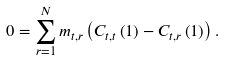<formula> <loc_0><loc_0><loc_500><loc_500>0 = \sum _ { r = 1 } ^ { N } m _ { t , r } \left ( C _ { t , t } \left ( 1 \right ) - C _ { t , r } \left ( 1 \right ) \right ) .</formula> 